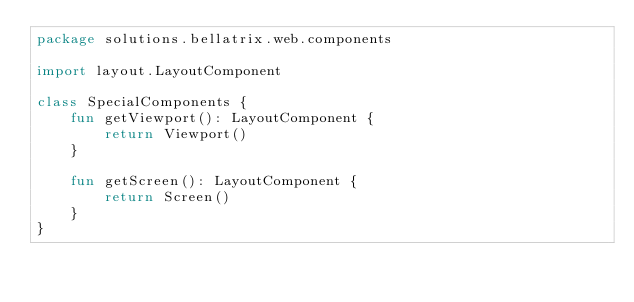<code> <loc_0><loc_0><loc_500><loc_500><_Kotlin_>package solutions.bellatrix.web.components

import layout.LayoutComponent

class SpecialComponents {
    fun getViewport(): LayoutComponent {
        return Viewport()
    }

    fun getScreen(): LayoutComponent {
        return Screen()
    }
}</code> 